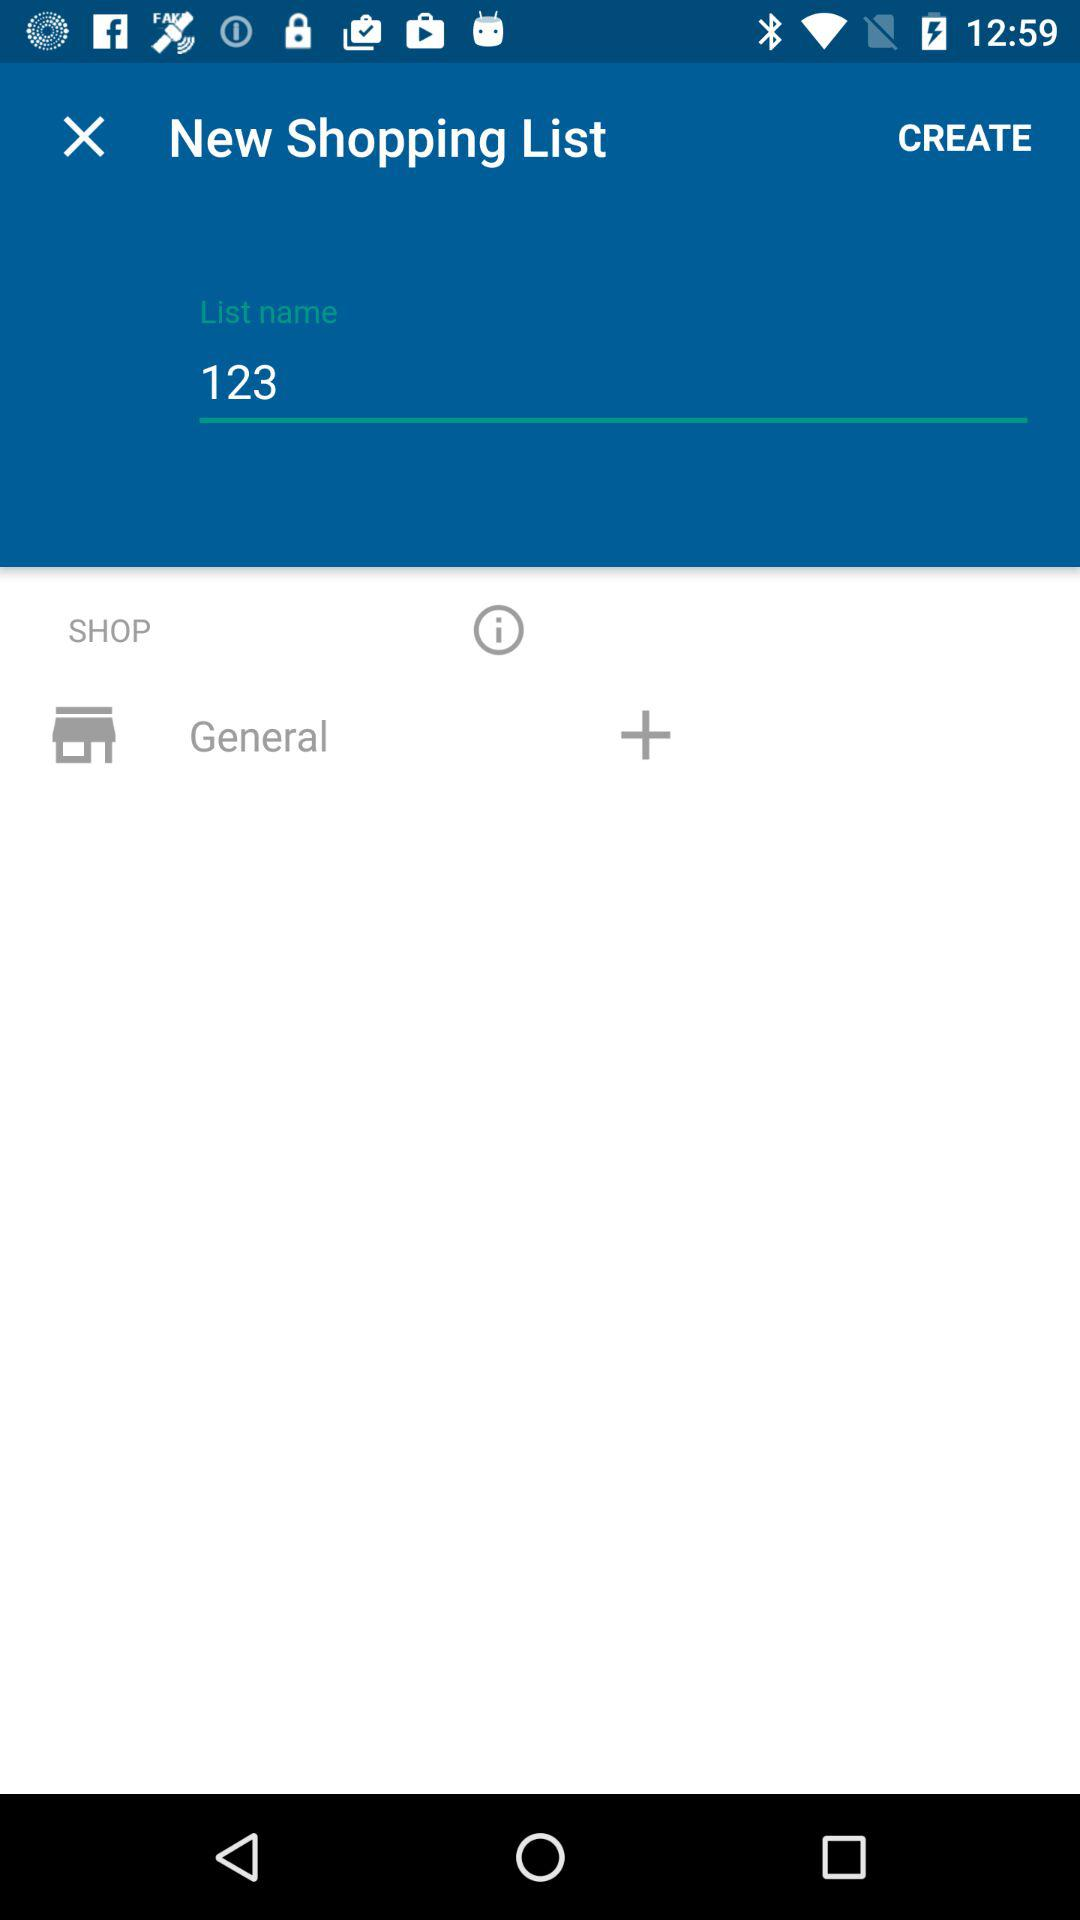What is the list name? The list name is "123". 